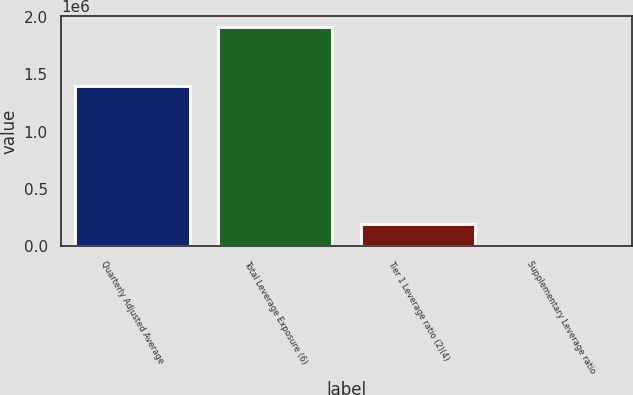<chart> <loc_0><loc_0><loc_500><loc_500><bar_chart><fcel>Quarterly Adjusted Average<fcel>Total Leverage Exposure (6)<fcel>Tier 1 Leverage ratio (2)(4)<fcel>Supplementary Leverage ratio<nl><fcel>1.39903e+06<fcel>1.91482e+06<fcel>191488<fcel>6.86<nl></chart> 